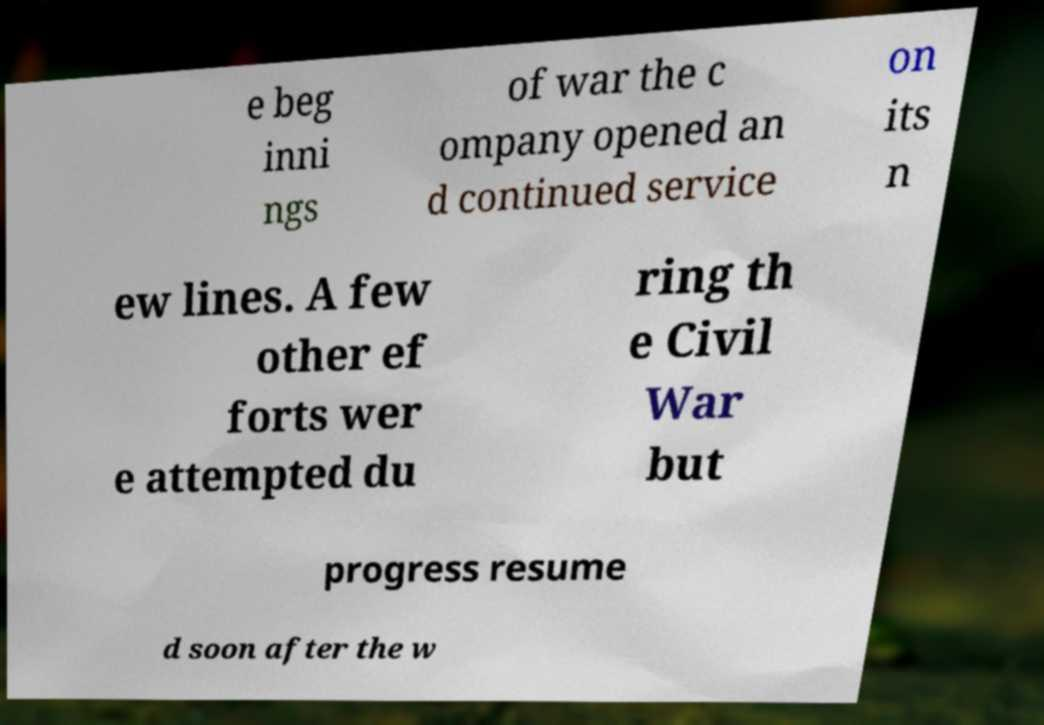Could you extract and type out the text from this image? e beg inni ngs of war the c ompany opened an d continued service on its n ew lines. A few other ef forts wer e attempted du ring th e Civil War but progress resume d soon after the w 